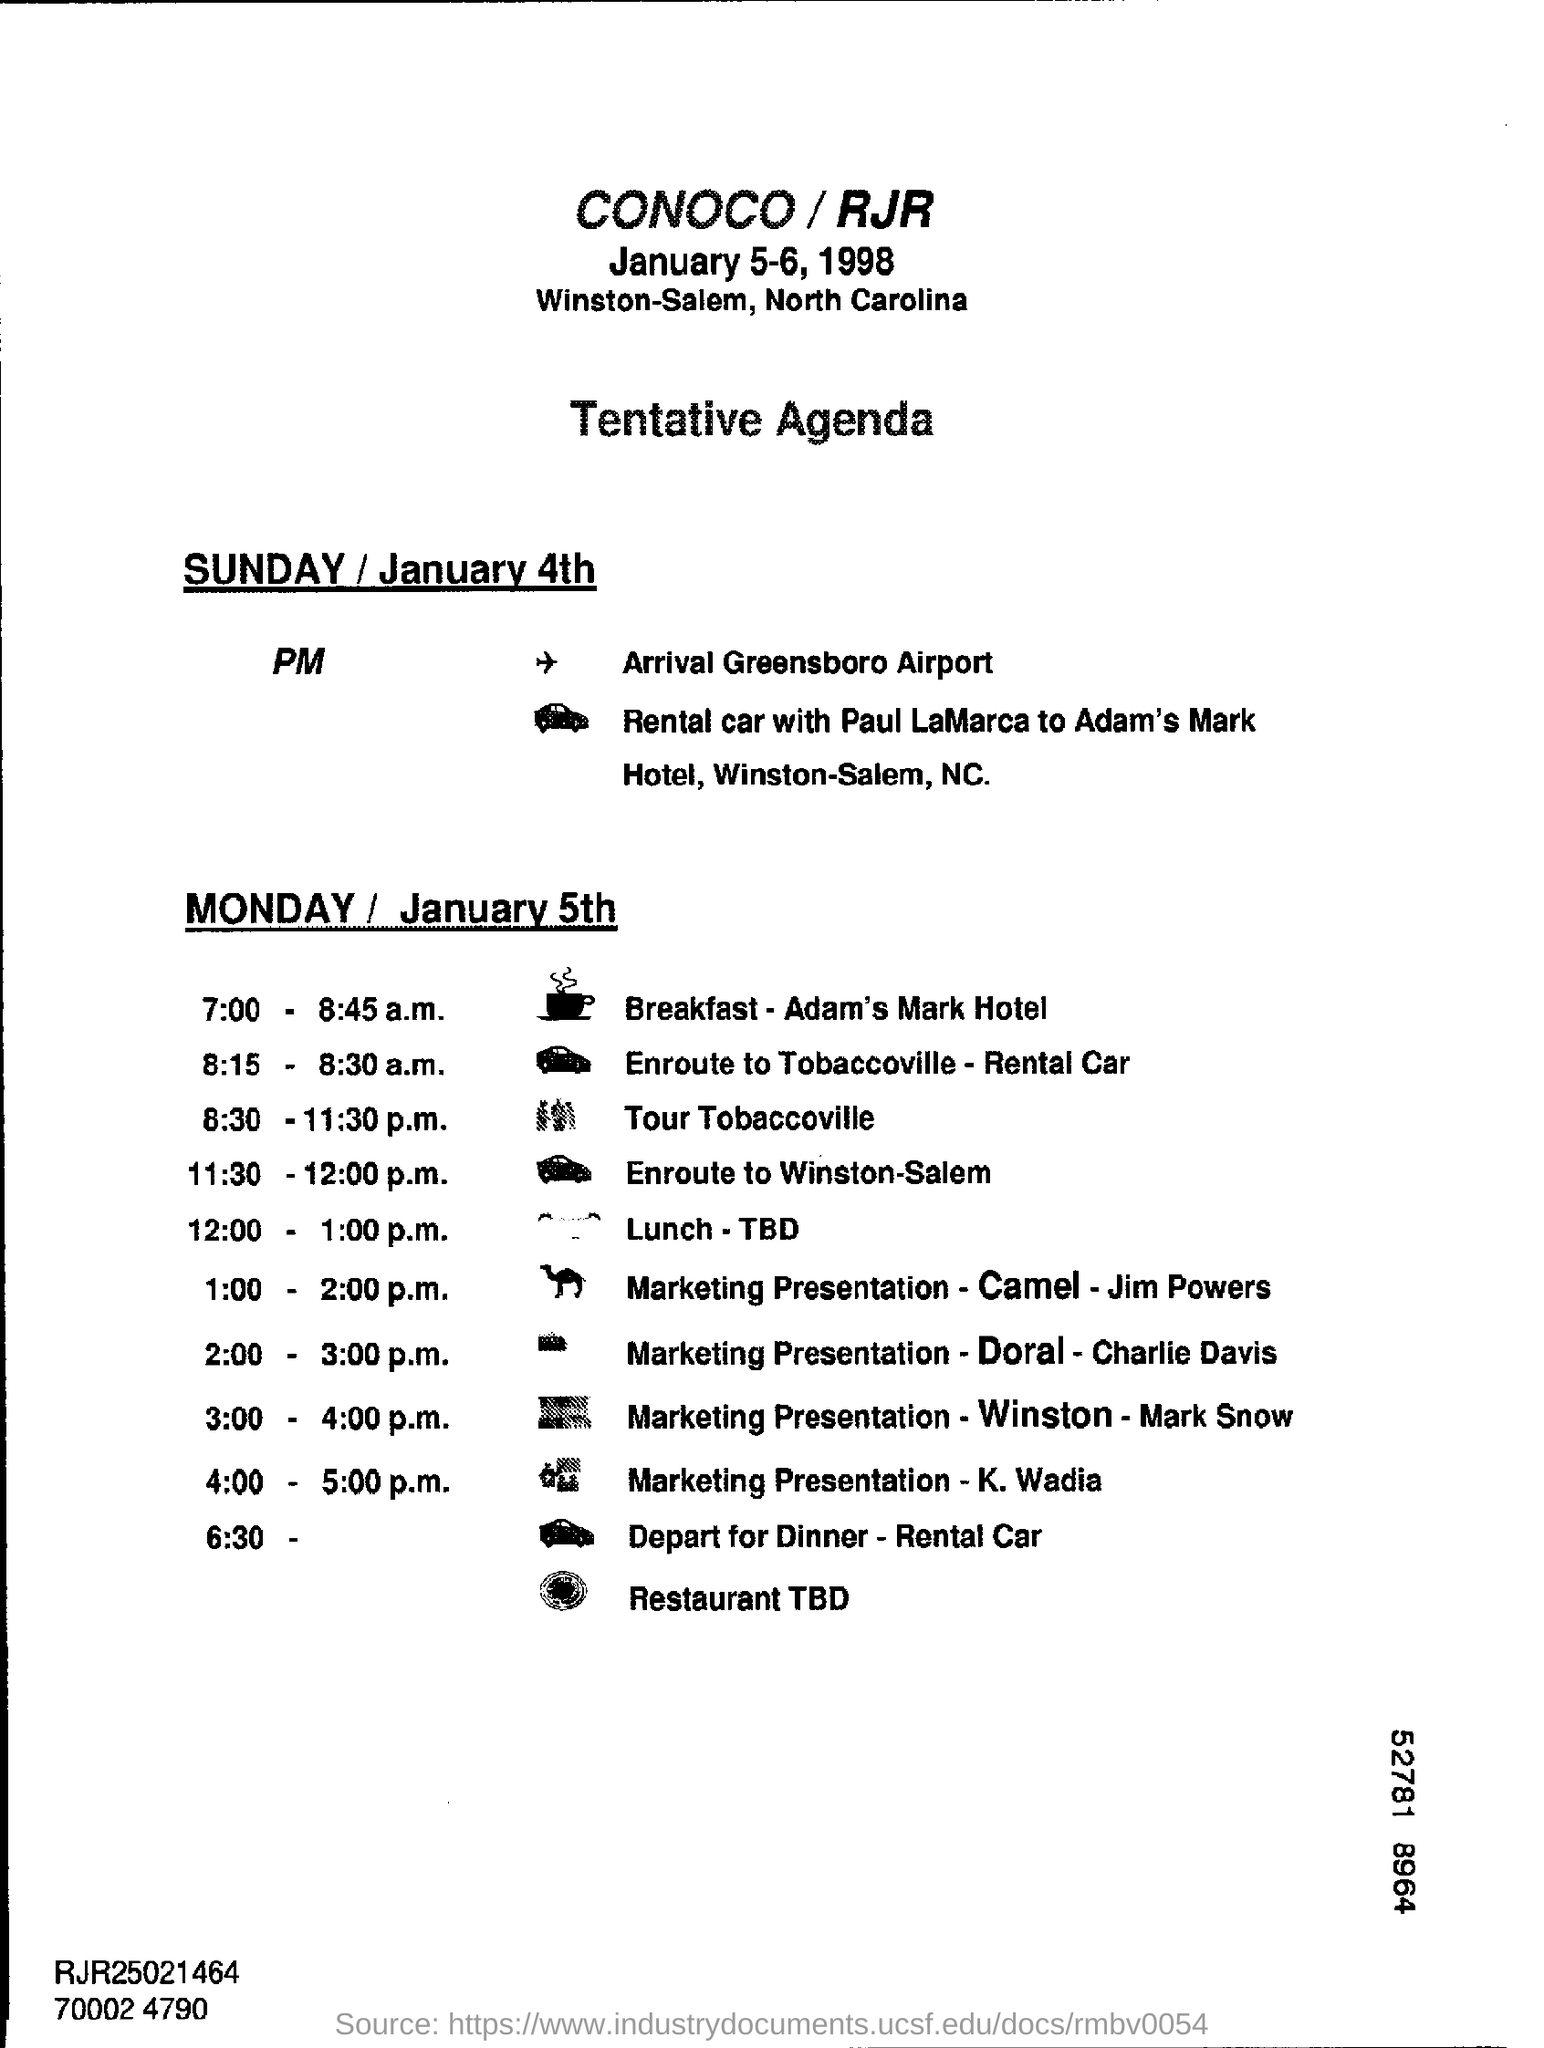What kind of document is this?
Your answer should be compact. Tentative Agenda. At what time, the Marketing Presentation - Camel - Jim Powers is scheduled?
Your response must be concise. 1:00 - 2:00 p.m. On which date, the Marketing Presentation - K. Wadia is scheduled to present?
Offer a terse response. MONDAY / January 5th. What is the date of arrival at Greensboro Airport?
Make the answer very short. SUNDAY / January 4th. 